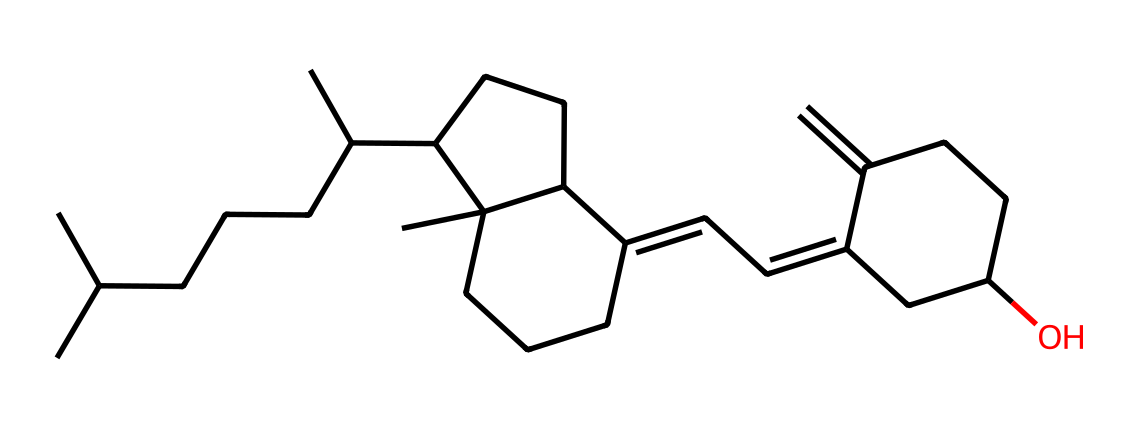What is the name of this vitamin? The SMILES representation corresponds to cholecalciferol, which is another name for vitamin D3. This can be inferred from knowledge of vitamin structures and their chemical identifiers.
Answer: cholecalciferol How many carbon atoms are present in this structure? By examining the SMILES representation, we count the number of 'C' characters to identify the carbon atoms. In this case, there are 27 carbon atoms present.
Answer: 27 What functional group is prominently featured in this vitamin? Analyzing the structure reveals the presence of a hydroxyl (-OH) group, which suggests that this vitamin has alcohol characteristics.
Answer: hydroxyl group What is the main role of vitamin D3 in the body? Vitamin D3 primarily assists in the absorption of calcium and phosphorus, which are crucial for maintaining bone health. This is a well-established function of this vitamin, derived from its biological role.
Answer: calcium absorption Does the structure suggest that this vitamin is hydrophilic or hydrophobic? The presence of long hydrocarbon chains and a single hydroxyl group indicates that vitamin D3 is predominantly hydrophobic. This conclusion is drawn from its structure comprising mostly non-polar bonds.
Answer: hydrophobic How many rings are within the molecular structure of vitamin D3? Inspecting the chemical structure, we identify multiple cycloalkane rings present in the molecule. Specifically, there are three rings present in vitamin D3.
Answer: 3 